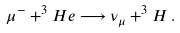<formula> <loc_0><loc_0><loc_500><loc_500>\mu ^ { - } + ^ { 3 } H e \longrightarrow \nu _ { \mu } + ^ { 3 } H \, .</formula> 